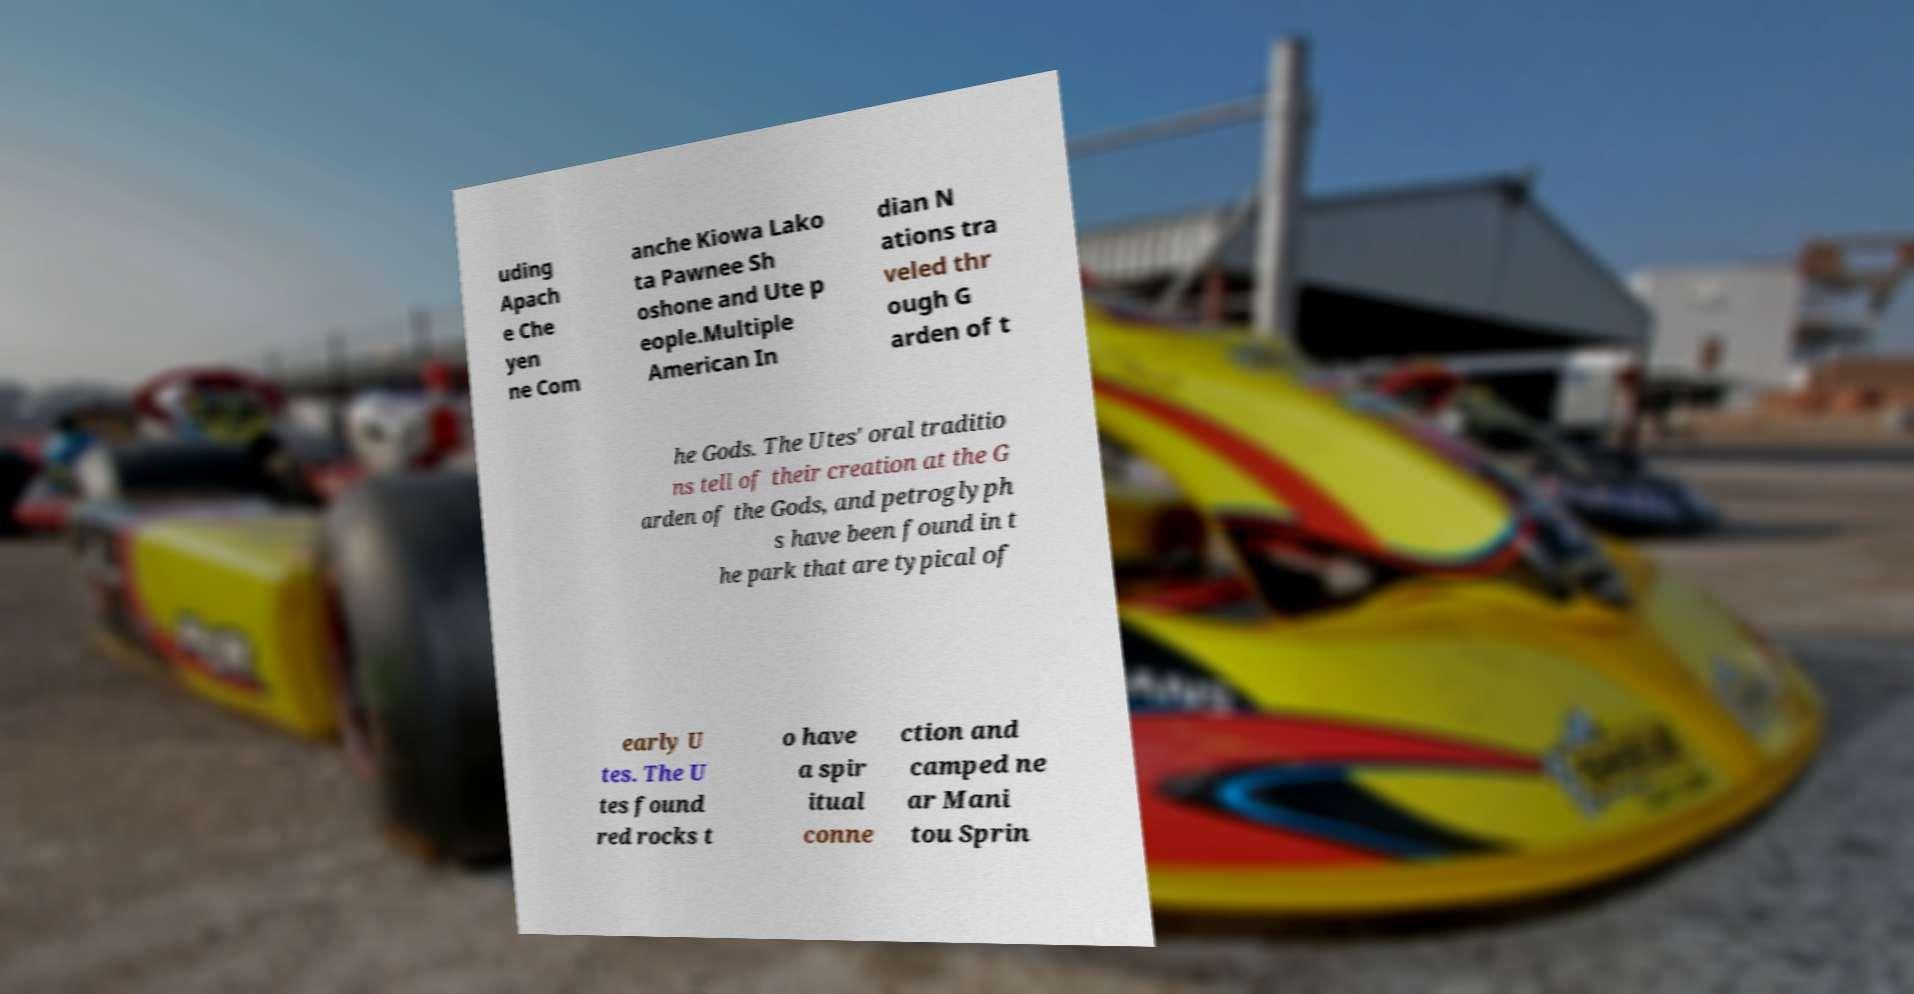Can you read and provide the text displayed in the image?This photo seems to have some interesting text. Can you extract and type it out for me? uding Apach e Che yen ne Com anche Kiowa Lako ta Pawnee Sh oshone and Ute p eople.Multiple American In dian N ations tra veled thr ough G arden of t he Gods. The Utes' oral traditio ns tell of their creation at the G arden of the Gods, and petroglyph s have been found in t he park that are typical of early U tes. The U tes found red rocks t o have a spir itual conne ction and camped ne ar Mani tou Sprin 